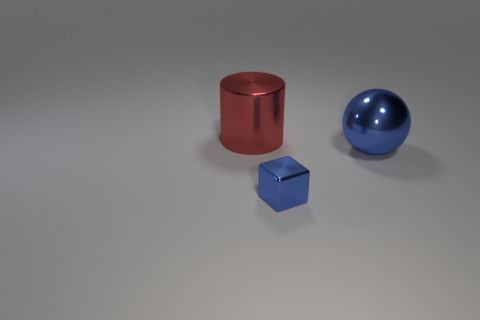Add 2 big blue things. How many objects exist? 5 Subtract all blocks. How many objects are left? 2 Subtract 1 balls. How many balls are left? 0 Subtract all blue cylinders. Subtract all cyan blocks. How many cylinders are left? 1 Subtract all green spheres. How many cyan cylinders are left? 0 Subtract all metal cylinders. Subtract all small blue cubes. How many objects are left? 1 Add 1 red things. How many red things are left? 2 Add 2 red cylinders. How many red cylinders exist? 3 Subtract 0 blue cylinders. How many objects are left? 3 